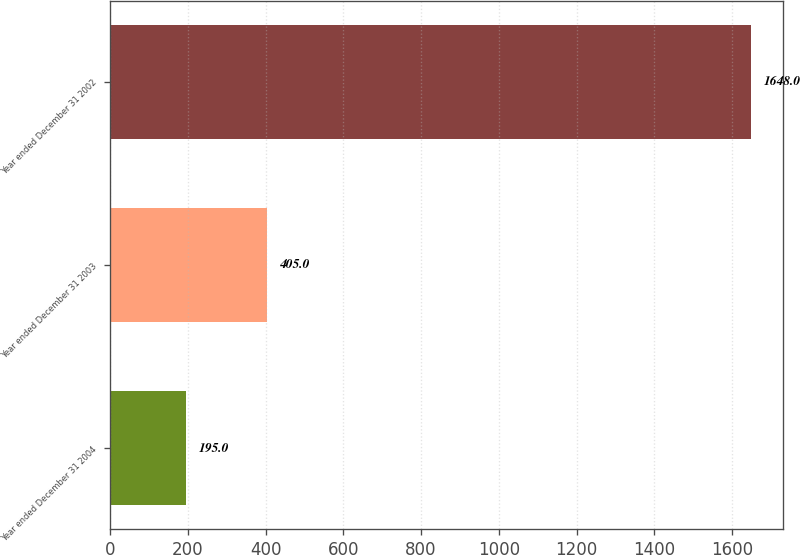Convert chart. <chart><loc_0><loc_0><loc_500><loc_500><bar_chart><fcel>Year ended December 31 2004<fcel>Year ended December 31 2003<fcel>Year ended December 31 2002<nl><fcel>195<fcel>405<fcel>1648<nl></chart> 